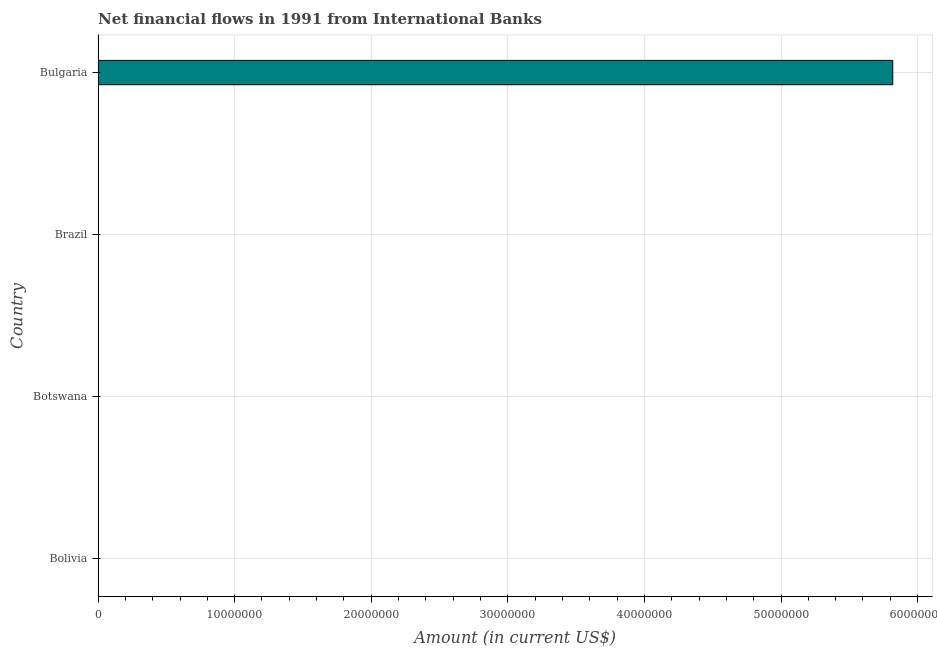Does the graph contain grids?
Make the answer very short. Yes. What is the title of the graph?
Make the answer very short. Net financial flows in 1991 from International Banks. What is the label or title of the X-axis?
Provide a succinct answer. Amount (in current US$). What is the label or title of the Y-axis?
Provide a short and direct response. Country. What is the net financial flows from ibrd in Brazil?
Offer a very short reply. 0. Across all countries, what is the maximum net financial flows from ibrd?
Give a very brief answer. 5.82e+07. Across all countries, what is the minimum net financial flows from ibrd?
Your response must be concise. 0. In which country was the net financial flows from ibrd maximum?
Make the answer very short. Bulgaria. What is the sum of the net financial flows from ibrd?
Offer a terse response. 5.82e+07. What is the average net financial flows from ibrd per country?
Keep it short and to the point. 1.45e+07. What is the median net financial flows from ibrd?
Your response must be concise. 0. What is the difference between the highest and the lowest net financial flows from ibrd?
Your response must be concise. 5.82e+07. In how many countries, is the net financial flows from ibrd greater than the average net financial flows from ibrd taken over all countries?
Make the answer very short. 1. How many bars are there?
Offer a terse response. 1. Are all the bars in the graph horizontal?
Offer a very short reply. Yes. What is the Amount (in current US$) in Bolivia?
Keep it short and to the point. 0. What is the Amount (in current US$) of Botswana?
Keep it short and to the point. 0. What is the Amount (in current US$) in Bulgaria?
Provide a short and direct response. 5.82e+07. 